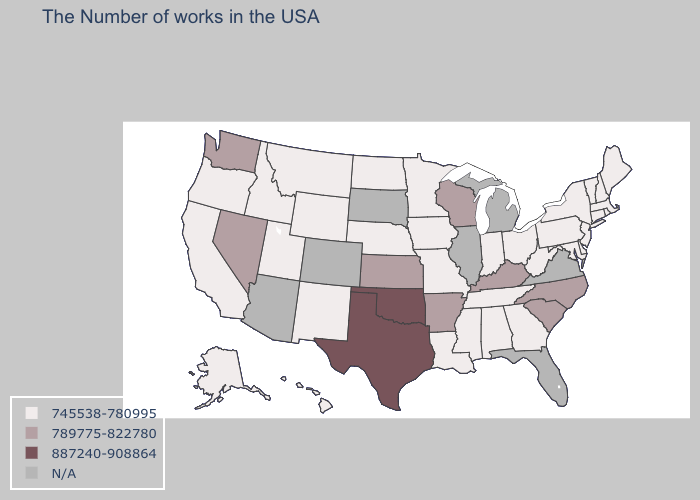Which states have the lowest value in the South?
Be succinct. Delaware, Maryland, West Virginia, Georgia, Alabama, Tennessee, Mississippi, Louisiana. Does Texas have the highest value in the USA?
Short answer required. Yes. What is the lowest value in the USA?
Give a very brief answer. 745538-780995. What is the lowest value in the USA?
Concise answer only. 745538-780995. Does the first symbol in the legend represent the smallest category?
Keep it brief. Yes. What is the lowest value in the USA?
Concise answer only. 745538-780995. What is the lowest value in the Northeast?
Concise answer only. 745538-780995. Name the states that have a value in the range N/A?
Short answer required. Virginia, Florida, Michigan, Illinois, South Dakota, Colorado, Arizona. What is the value of Virginia?
Short answer required. N/A. What is the value of California?
Give a very brief answer. 745538-780995. Name the states that have a value in the range 745538-780995?
Keep it brief. Maine, Massachusetts, Rhode Island, New Hampshire, Vermont, Connecticut, New York, New Jersey, Delaware, Maryland, Pennsylvania, West Virginia, Ohio, Georgia, Indiana, Alabama, Tennessee, Mississippi, Louisiana, Missouri, Minnesota, Iowa, Nebraska, North Dakota, Wyoming, New Mexico, Utah, Montana, Idaho, California, Oregon, Alaska, Hawaii. Does Minnesota have the lowest value in the USA?
Be succinct. Yes. Does Minnesota have the lowest value in the USA?
Give a very brief answer. Yes. 